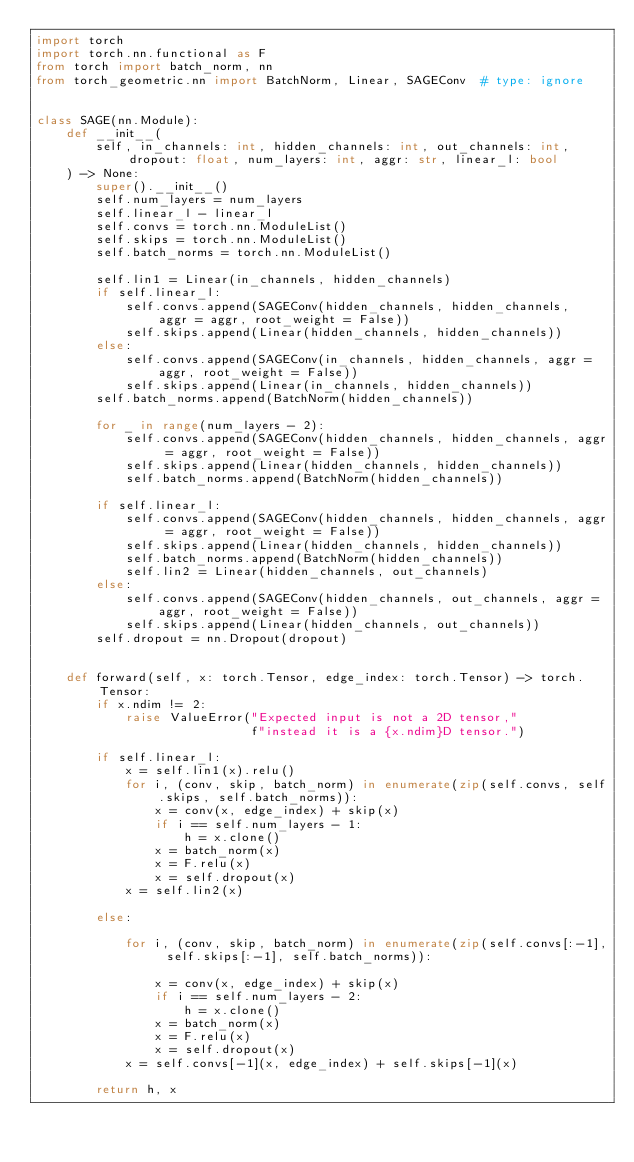<code> <loc_0><loc_0><loc_500><loc_500><_Python_>import torch
import torch.nn.functional as F
from torch import batch_norm, nn
from torch_geometric.nn import BatchNorm, Linear, SAGEConv  # type: ignore


class SAGE(nn.Module):
    def __init__(
        self, in_channels: int, hidden_channels: int, out_channels: int, dropout: float, num_layers: int, aggr: str, linear_l: bool
    ) -> None:
        super().__init__()
        self.num_layers = num_layers
        self.linear_l - linear_l
        self.convs = torch.nn.ModuleList()
        self.skips = torch.nn.ModuleList()
        self.batch_norms = torch.nn.ModuleList()

        self.lin1 = Linear(in_channels, hidden_channels)
        if self.linear_l:
            self.convs.append(SAGEConv(hidden_channels, hidden_channels,  aggr = aggr, root_weight = False))
            self.skips.append(Linear(hidden_channels, hidden_channels))
        else:
            self.convs.append(SAGEConv(in_channels, hidden_channels, aggr = aggr, root_weight = False))
            self.skips.append(Linear(in_channels, hidden_channels))
        self.batch_norms.append(BatchNorm(hidden_channels))

        for _ in range(num_layers - 2):
            self.convs.append(SAGEConv(hidden_channels, hidden_channels, aggr = aggr, root_weight = False))
            self.skips.append(Linear(hidden_channels, hidden_channels))
            self.batch_norms.append(BatchNorm(hidden_channels))

        if self.linear_l:
            self.convs.append(SAGEConv(hidden_channels, hidden_channels, aggr = aggr, root_weight = False))
            self.skips.append(Linear(hidden_channels, hidden_channels))
            self.batch_norms.append(BatchNorm(hidden_channels))
            self.lin2 = Linear(hidden_channels, out_channels)
        else:
            self.convs.append(SAGEConv(hidden_channels, out_channels, aggr = aggr, root_weight = False))
            self.skips.append(Linear(hidden_channels, out_channels))
        self.dropout = nn.Dropout(dropout)


    def forward(self, x: torch.Tensor, edge_index: torch.Tensor) -> torch.Tensor:
        if x.ndim != 2:
            raise ValueError("Expected input is not a 2D tensor,"
                             f"instead it is a {x.ndim}D tensor.")

        if self.linear_l:
            x = self.lin1(x).relu()
            for i, (conv, skip, batch_norm) in enumerate(zip(self.convs, self.skips, self.batch_norms)):
                x = conv(x, edge_index) + skip(x)
                if i == self.num_layers - 1:
                    h = x.clone()
                x = batch_norm(x)
                x = F.relu(x)
                x = self.dropout(x)
            x = self.lin2(x)

        else:

            for i, (conv, skip, batch_norm) in enumerate(zip(self.convs[:-1], self.skips[:-1], self.batch_norms)):

                x = conv(x, edge_index) + skip(x)
                if i == self.num_layers - 2:
                    h = x.clone()
                x = batch_norm(x)
                x = F.relu(x)
                x = self.dropout(x)
            x = self.convs[-1](x, edge_index) + self.skips[-1](x)

        return h, x</code> 